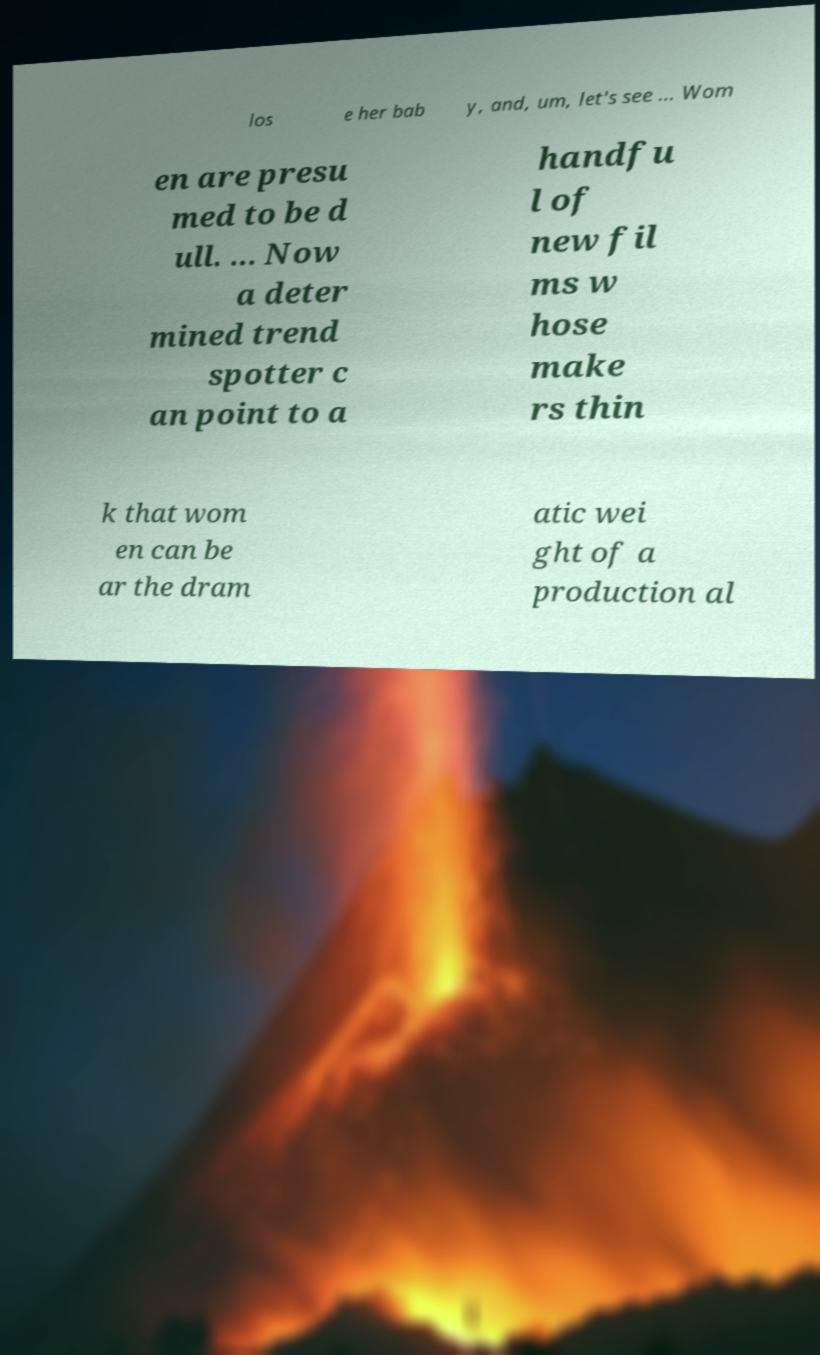Can you accurately transcribe the text from the provided image for me? los e her bab y, and, um, let's see ... Wom en are presu med to be d ull. ... Now a deter mined trend spotter c an point to a handfu l of new fil ms w hose make rs thin k that wom en can be ar the dram atic wei ght of a production al 